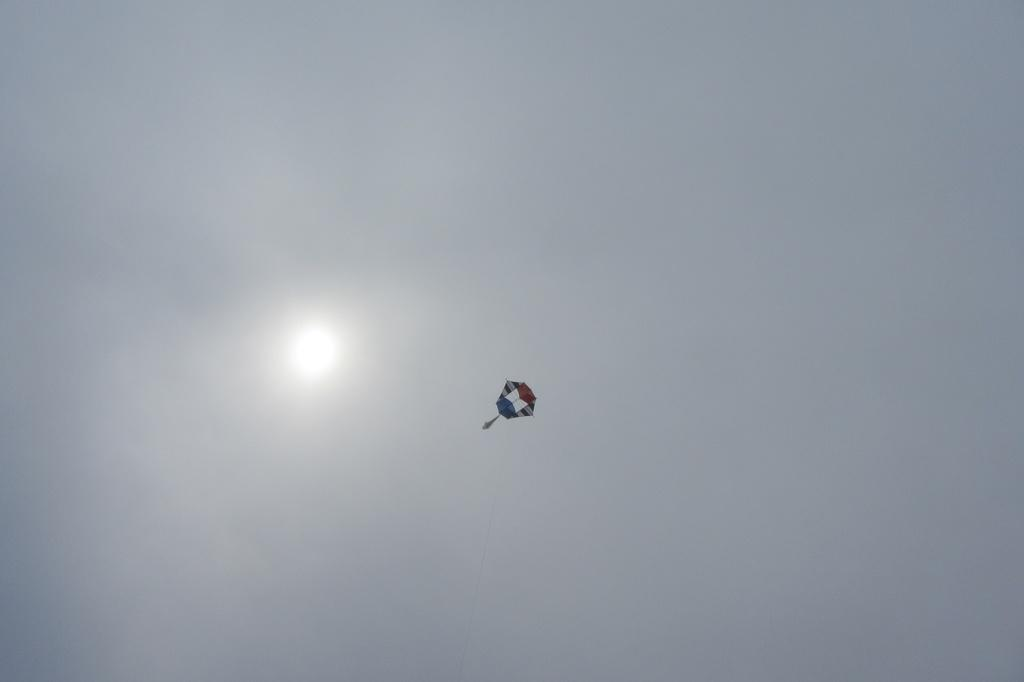What is flying in the sky in the image? There is a kite flying in the sky in the image. What can be seen behind the kite in the sky? The sun is visible behind the kite in the image. How many pizzas are being delivered through the gate in the image? There are no pizzas or gates present in the image; it only features a kite flying in the sky and the sun behind it. 